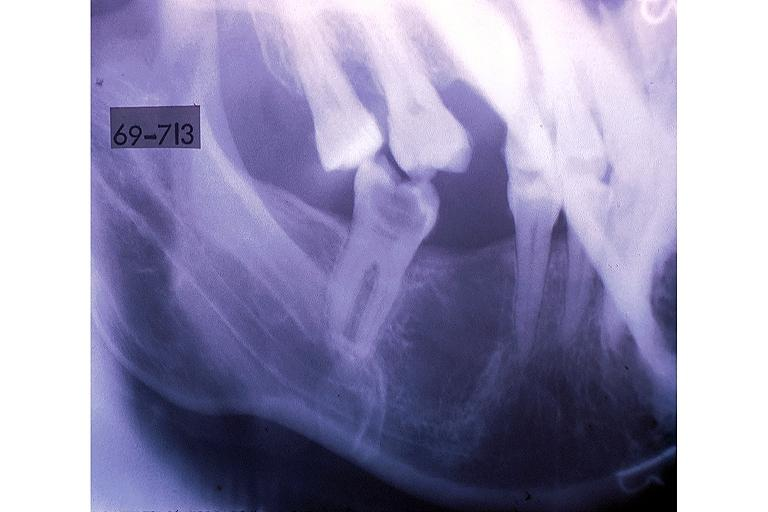s oral present?
Answer the question using a single word or phrase. Yes 